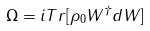<formula> <loc_0><loc_0><loc_500><loc_500>\Omega = i T r [ \rho _ { 0 } W ^ { \dagger } d W ]</formula> 